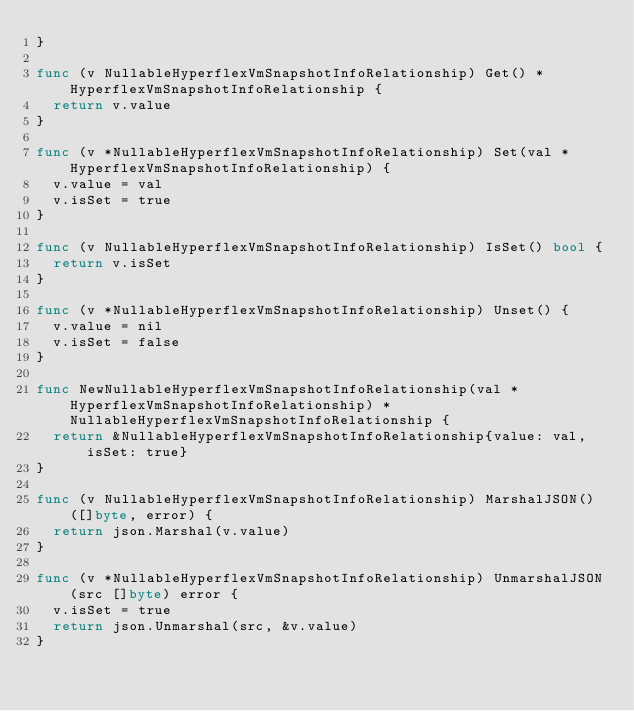<code> <loc_0><loc_0><loc_500><loc_500><_Go_>}

func (v NullableHyperflexVmSnapshotInfoRelationship) Get() *HyperflexVmSnapshotInfoRelationship {
	return v.value
}

func (v *NullableHyperflexVmSnapshotInfoRelationship) Set(val *HyperflexVmSnapshotInfoRelationship) {
	v.value = val
	v.isSet = true
}

func (v NullableHyperflexVmSnapshotInfoRelationship) IsSet() bool {
	return v.isSet
}

func (v *NullableHyperflexVmSnapshotInfoRelationship) Unset() {
	v.value = nil
	v.isSet = false
}

func NewNullableHyperflexVmSnapshotInfoRelationship(val *HyperflexVmSnapshotInfoRelationship) *NullableHyperflexVmSnapshotInfoRelationship {
	return &NullableHyperflexVmSnapshotInfoRelationship{value: val, isSet: true}
}

func (v NullableHyperflexVmSnapshotInfoRelationship) MarshalJSON() ([]byte, error) {
	return json.Marshal(v.value)
}

func (v *NullableHyperflexVmSnapshotInfoRelationship) UnmarshalJSON(src []byte) error {
	v.isSet = true
	return json.Unmarshal(src, &v.value)
}


</code> 